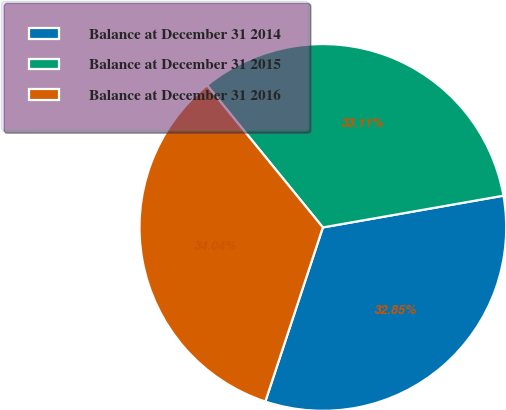<chart> <loc_0><loc_0><loc_500><loc_500><pie_chart><fcel>Balance at December 31 2014<fcel>Balance at December 31 2015<fcel>Balance at December 31 2016<nl><fcel>32.85%<fcel>33.11%<fcel>34.04%<nl></chart> 